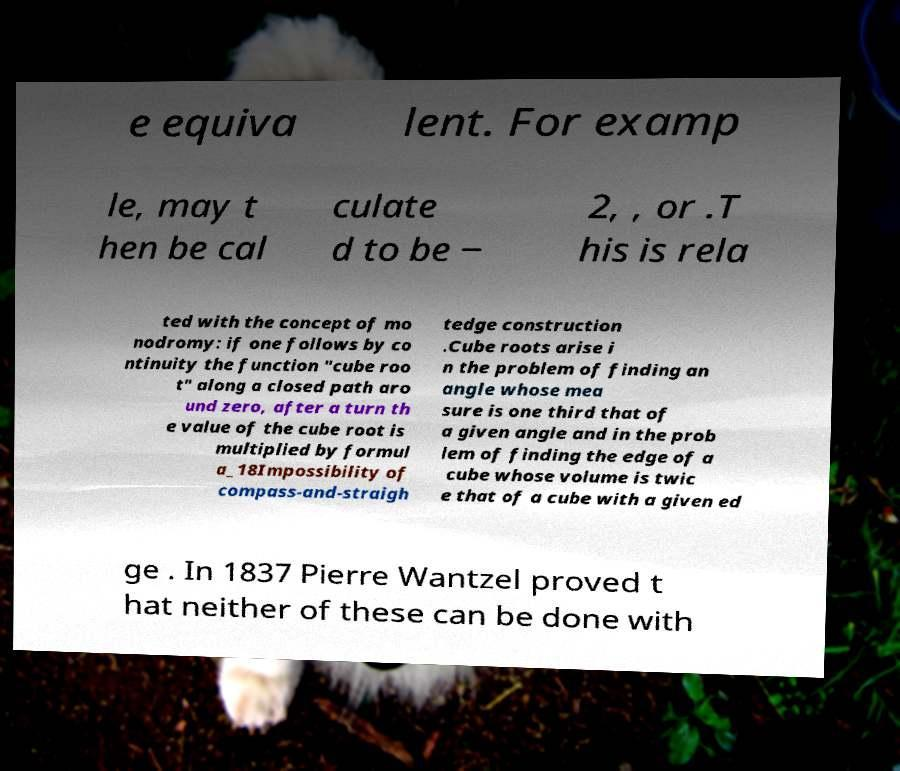I need the written content from this picture converted into text. Can you do that? e equiva lent. For examp le, may t hen be cal culate d to be − 2, , or .T his is rela ted with the concept of mo nodromy: if one follows by co ntinuity the function "cube roo t" along a closed path aro und zero, after a turn th e value of the cube root is multiplied by formul a_18Impossibility of compass-and-straigh tedge construction .Cube roots arise i n the problem of finding an angle whose mea sure is one third that of a given angle and in the prob lem of finding the edge of a cube whose volume is twic e that of a cube with a given ed ge . In 1837 Pierre Wantzel proved t hat neither of these can be done with 